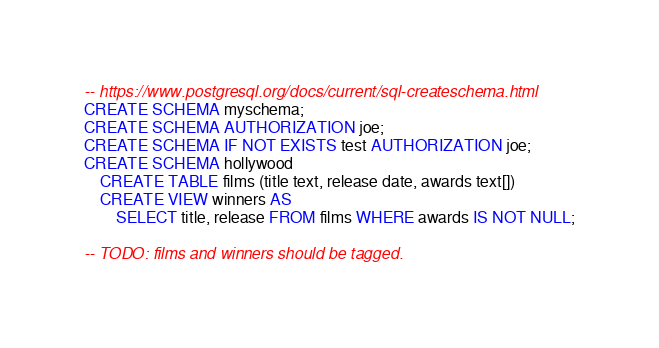<code> <loc_0><loc_0><loc_500><loc_500><_SQL_>-- https://www.postgresql.org/docs/current/sql-createschema.html
CREATE SCHEMA myschema;
CREATE SCHEMA AUTHORIZATION joe;
CREATE SCHEMA IF NOT EXISTS test AUTHORIZATION joe;
CREATE SCHEMA hollywood
    CREATE TABLE films (title text, release date, awards text[])
    CREATE VIEW winners AS
        SELECT title, release FROM films WHERE awards IS NOT NULL;

-- TODO: films and winners should be tagged.
</code> 